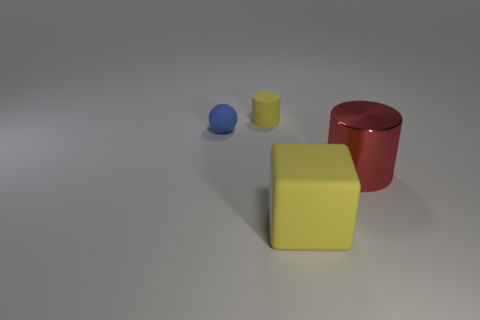Add 3 large red things. How many objects exist? 7 Subtract all blocks. How many objects are left? 3 Add 4 matte objects. How many matte objects are left? 7 Add 3 big red metallic cylinders. How many big red metallic cylinders exist? 4 Subtract 0 blue cylinders. How many objects are left? 4 Subtract all big objects. Subtract all small blocks. How many objects are left? 2 